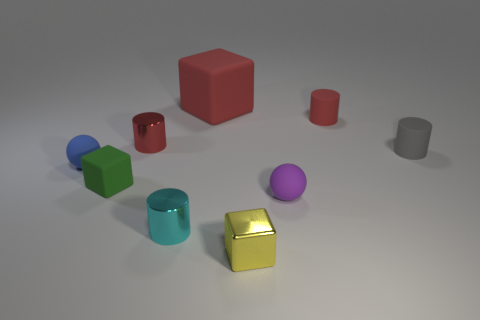What is the shape of the small rubber object that is both left of the purple rubber thing and behind the green matte thing?
Make the answer very short. Sphere. What number of things are either small red cylinders that are left of the tiny cyan shiny cylinder or tiny metallic cylinders that are on the left side of the tiny cyan metal object?
Provide a short and direct response. 1. What number of other things are there of the same size as the blue thing?
Give a very brief answer. 7. There is a small shiny cylinder that is behind the tiny green object; is it the same color as the large cube?
Make the answer very short. Yes. There is a object that is both right of the cyan cylinder and in front of the purple matte ball; how big is it?
Your response must be concise. Small. What number of big objects are cyan shiny cylinders or yellow objects?
Your response must be concise. 0. What shape is the small red matte thing on the right side of the red rubber block?
Ensure brevity in your answer.  Cylinder. What number of tiny gray cylinders are there?
Offer a very short reply. 1. Is the material of the green cube the same as the small purple ball?
Keep it short and to the point. Yes. Are there more tiny purple balls that are left of the small gray rubber cylinder than blue metal cylinders?
Make the answer very short. Yes. 